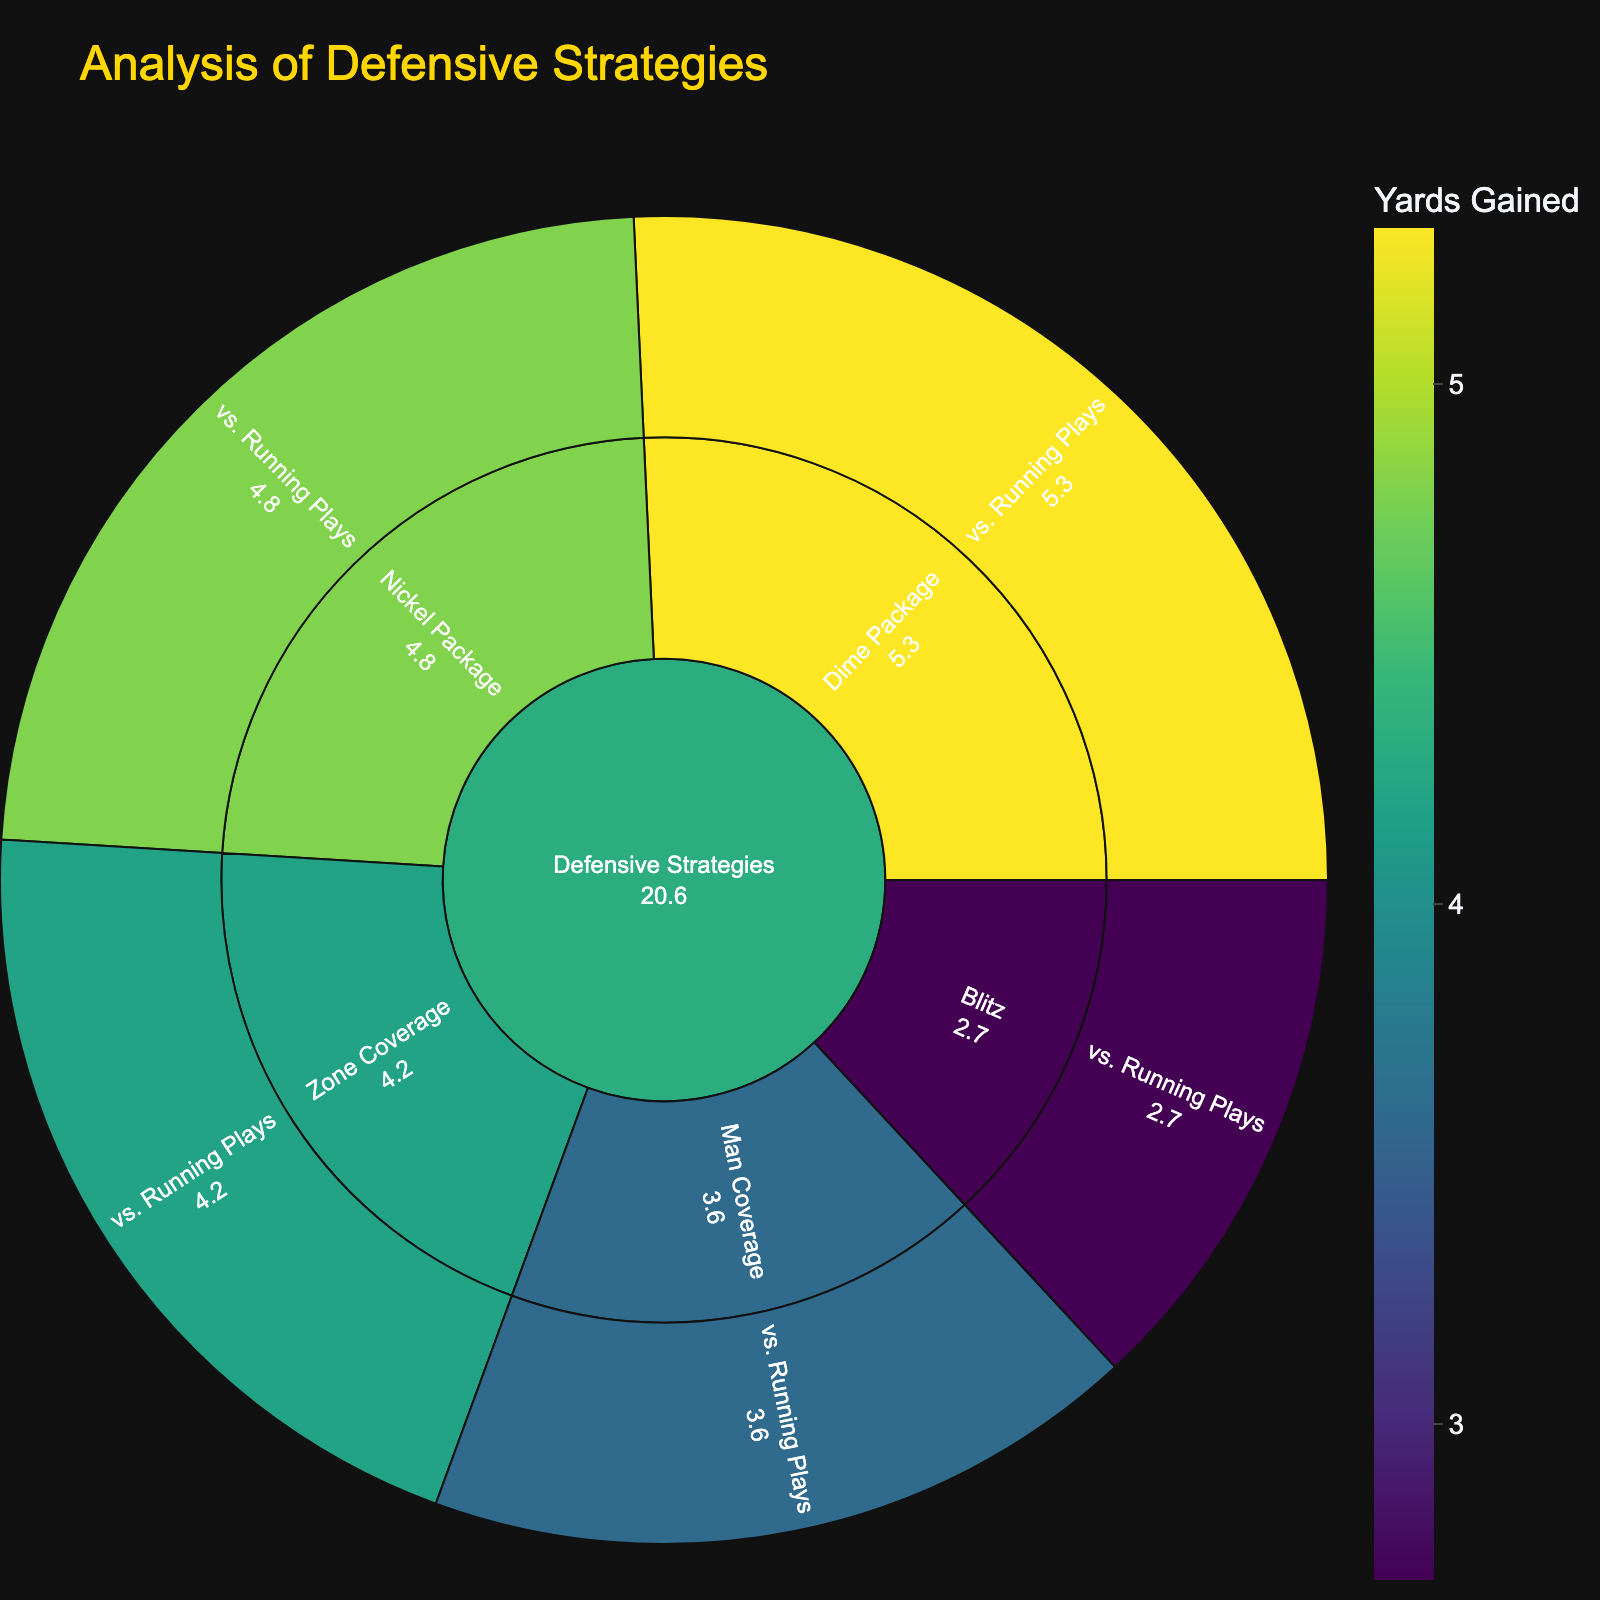What's the title of the figure? The title of the figure is directly displayed at the top in a larger, bold font.
Answer: Analysis of Defensive Strategies Which defensive strategy has the lowest average yards gained against running plays? To find the lowest average yards gained against running plays, look at the numerical values for each strategy under the category "vs. Running Plays" and identify the smallest value.
Answer: Blitz How much more yardage is gained on average against the Dime Package compared to the Blitz for running plays? Subtract the yards gained against the Blitz (2.7 yards) from the yards gained against the Dime Package (5.3 yards).
Answer: 2.6 What range of yardage values is represented in the color scale? The color scale bar indicates the minimum and maximum values displayed. Identify these values from the scale next to the plot.
Answer: 3 to 5 Which play type has more data points available in the plot, passing plays or running plays? Count the data points visible for both play types under each defensive strategy and compare these quantities.
Answer: Running plays What is the color representing the lowest yardage gained in the plot? Refer to the color scale provided and find the color associated with the smallest value displayed.
Answer: Dark green What is the average yards gained for running plays across all defensive strategies? Add the yards gained for running plays across all defensive strategies (3.6 + 4.2 + 2.7 + 4.8 + 5.3) and divide by the number of strategies (5).
Answer: 4.12 Which defensive strategy has the highest yardage gained for running plays? Compare the yardage values for running plays under each defensive strategy and identify the highest value.
Answer: Dime Package 